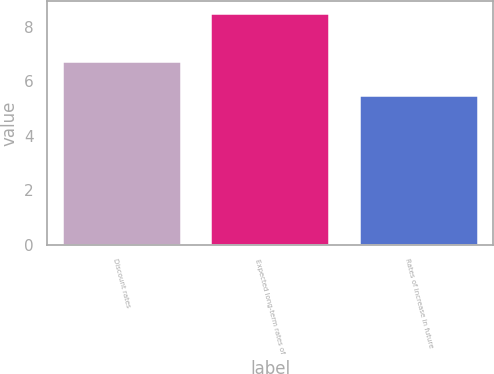Convert chart. <chart><loc_0><loc_0><loc_500><loc_500><bar_chart><fcel>Discount rates<fcel>Expected long-term rates of<fcel>Rates of increase in future<nl><fcel>6.75<fcel>8.5<fcel>5.5<nl></chart> 